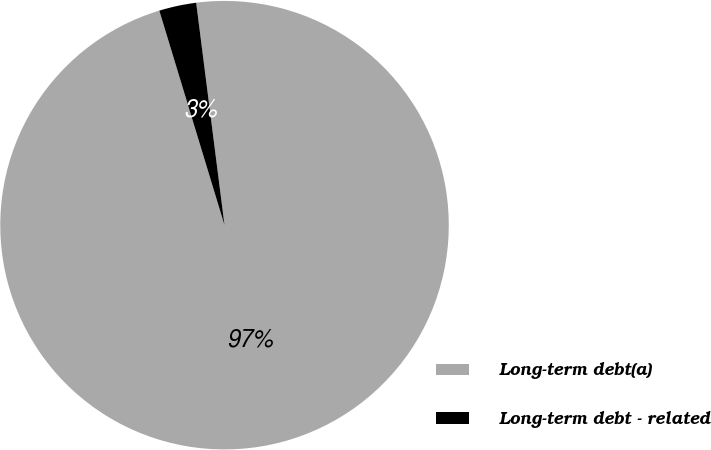Convert chart. <chart><loc_0><loc_0><loc_500><loc_500><pie_chart><fcel>Long-term debt(a)<fcel>Long-term debt - related<nl><fcel>97.32%<fcel>2.68%<nl></chart> 